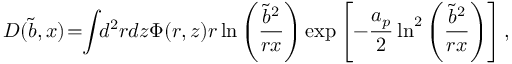Convert formula to latex. <formula><loc_0><loc_0><loc_500><loc_500>D ( \tilde { b } , x ) \, = \, \int \, d ^ { 2 } r d z \Phi ( r , z ) r \ln \left ( { \frac { \tilde { b } ^ { 2 } } { r x } } \right ) \exp \left [ - { \frac { a _ { p } } { 2 } } \ln ^ { 2 } \left ( { \frac { \tilde { b } ^ { 2 } } { r x } } \right ) \right ] ,</formula> 